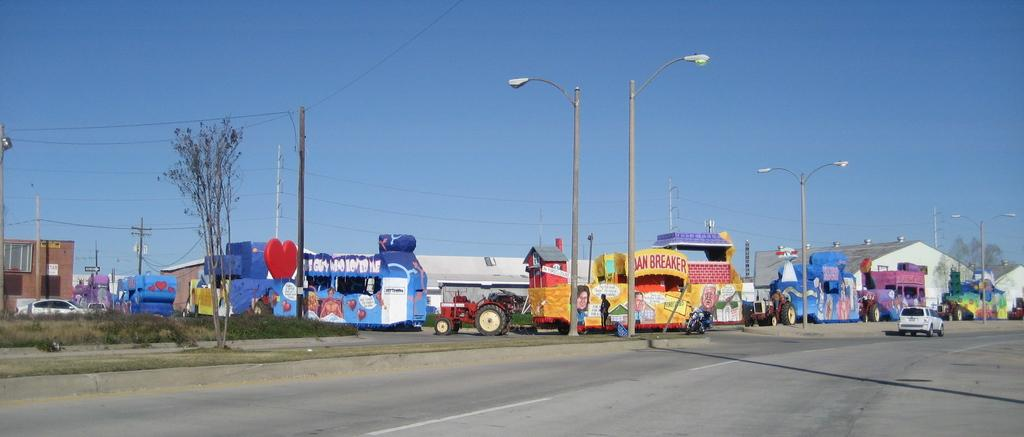What can be seen on the road in the image? There are vehicles on the road in the image. What structures are present to provide illumination at night? There are street lights in the image. What type of vegetation is visible in the image? There are trees in the image. What type of infrastructure is present for electricity? There are current poles in the image. What can be seen in the background of the image? There are buildings and the sky visible in the background of the image. Can you tell me what type of kite the doctor is flying in the image? There is no kite or doctor present in the image. What is the thing that the vehicles are chasing in the image? There is no indication in the image that the vehicles are chasing anything. 